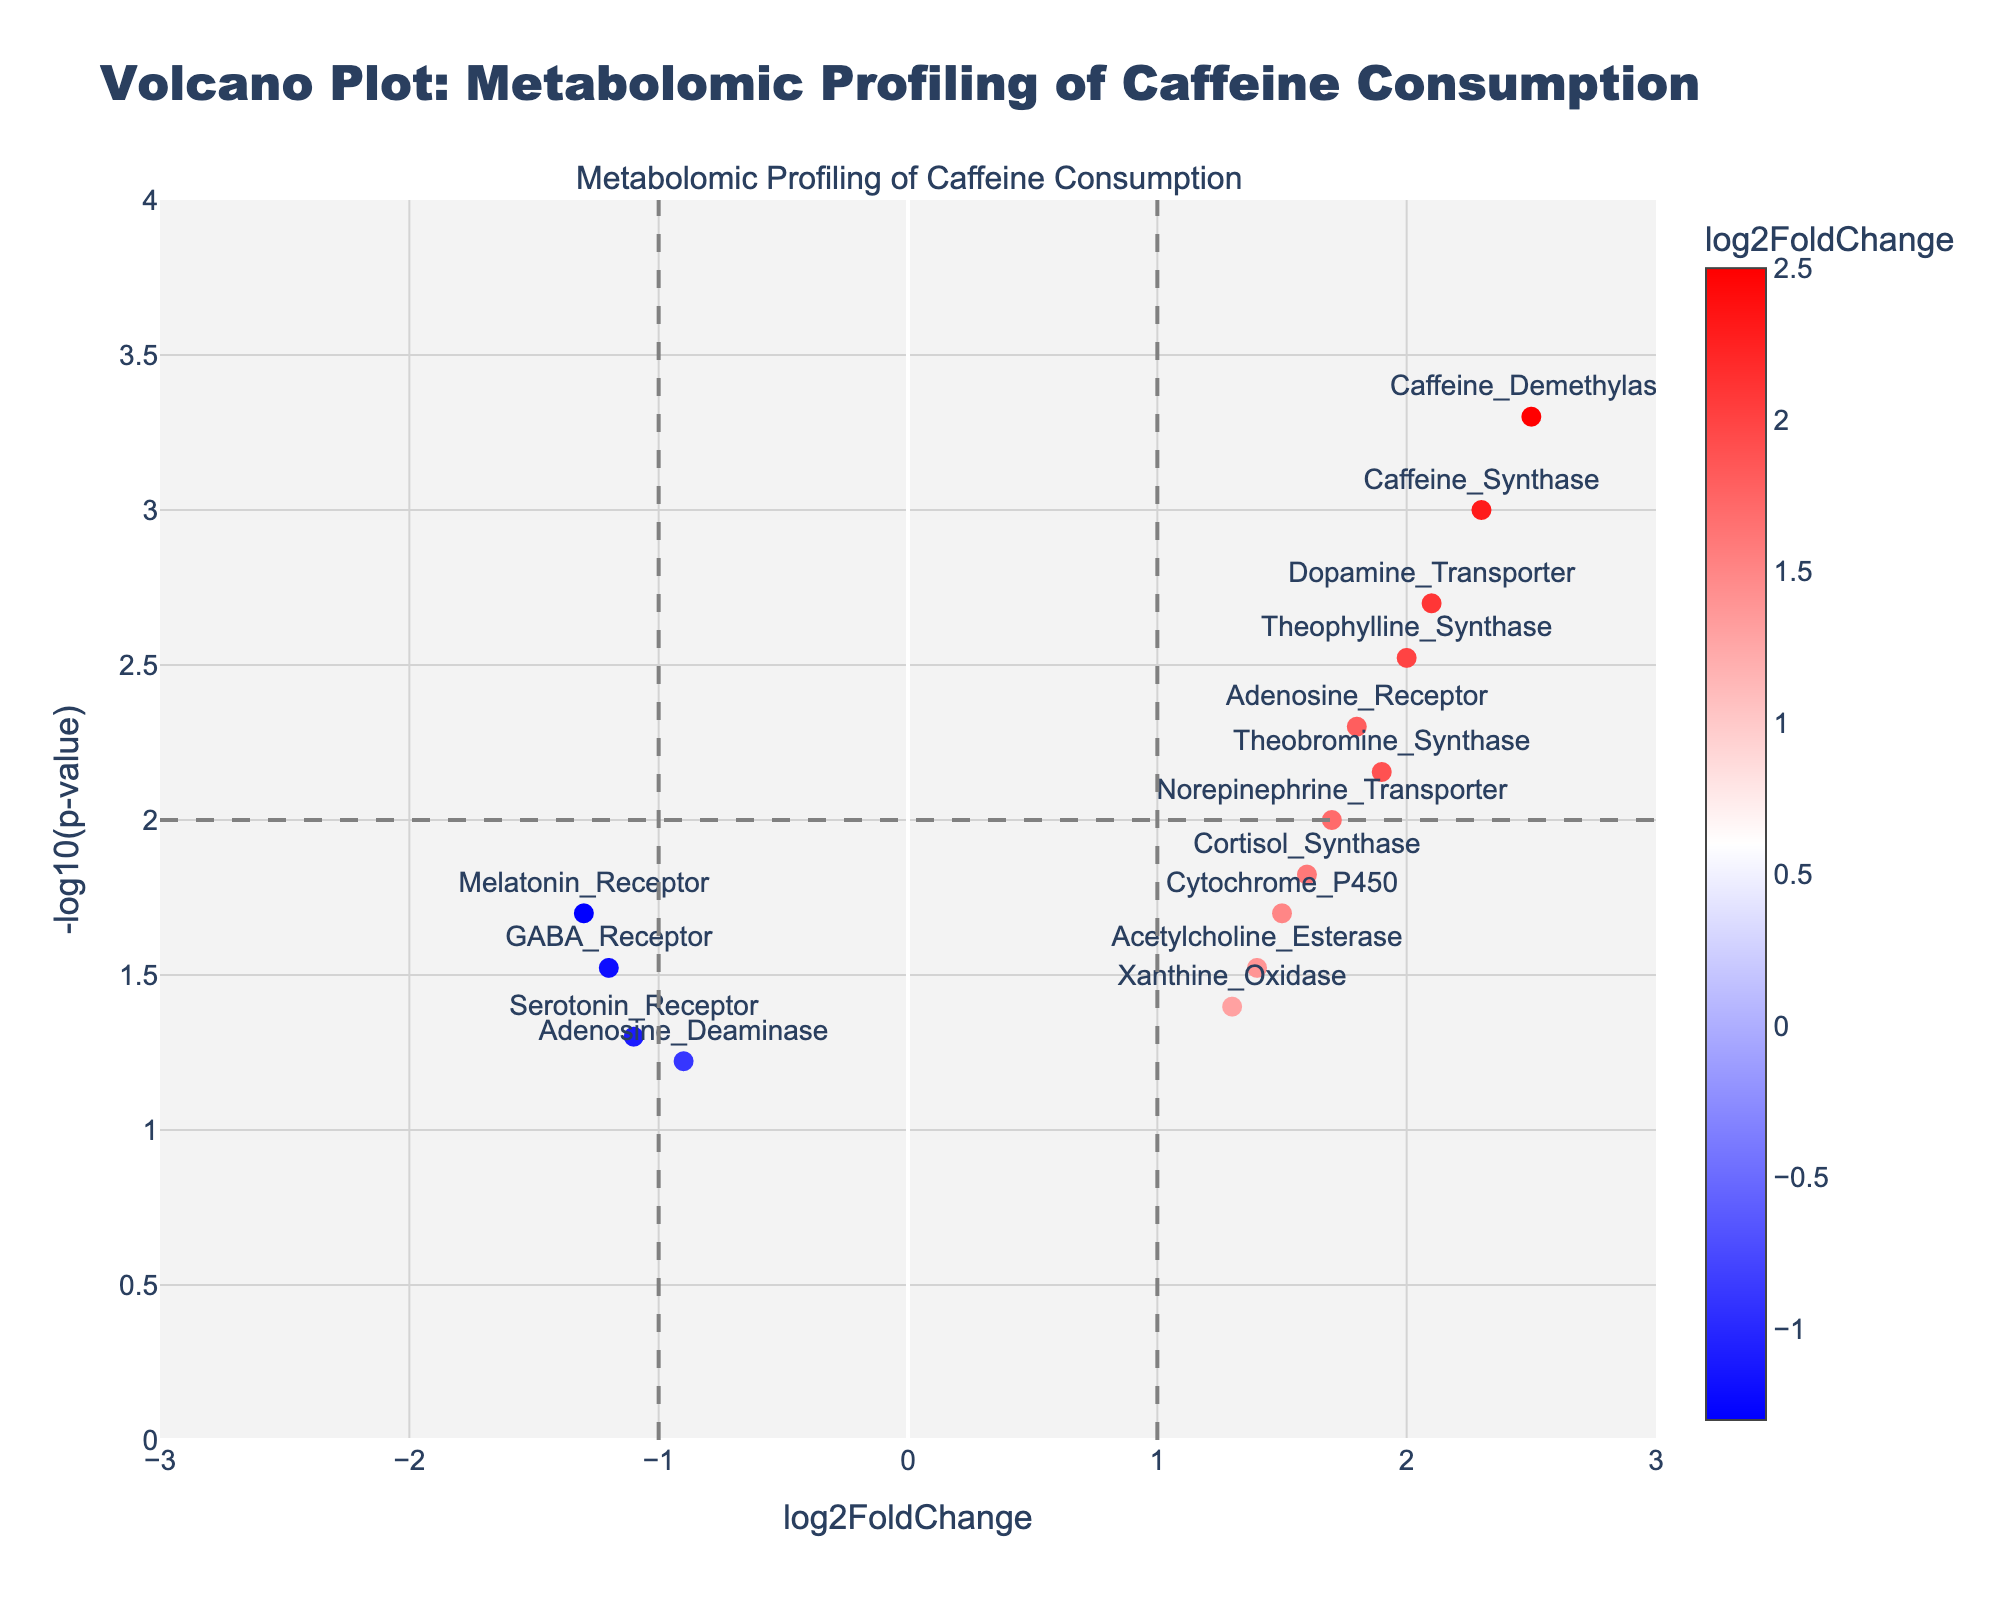What is the title of the plot? The title can be found at the top of the plot. It usually summarizes the main topic or focus of the visualization.
Answer: Volcano Plot: Metabolomic Profiling of Caffeine Consumption What is the highest log2FoldChange value and which gene does it correspond to? To find this, look at the x-axis (log2FoldChange) and identify the point that is furthest to the right. Check the text label associated with this point.
Answer: 2.5, Caffeine_Demethylase Which gene has the lowest -log10(p-value)? Look at the y-axis (-log10(p-value)) and find the point that is closest to the bottom. The text label next to this point will indicate the gene.
Answer: Adenosine_Deaminase How many genes have a log2FoldChange greater than 1.5? Identify data points with x-axis values greater than 1.5. Count these points based on their position on the x-axis.
Answer: 7 Which genes show a negative log2FoldChange, and what are their -log10(p-value) values? Look for points with x-axis values less than 0, indicating negative log2FoldChange. Check the y-axis values for these points.
Answer: GABA_Receptor (1.52), Adenosine_Deaminase (1.22), Serotonin_Receptor (1.30), Melatonin_Receptor (1.70) Is there a gene with a log2FoldChange between 1.5 and 2.0 and a -log10(p-value) greater than 2? Find points in the specified range on the x-axis (1.5 < x < 2.0) and check their positions on the y-axis to see if they are greater than 2.
Answer: No Which gene is marked with the highest -log10(p-value), and what is its log2FoldChange? Look at the highest point on the y-axis and identify the corresponding x-axis value and gene name.
Answer: Caffeine_Demethylase, 2.5 What is the color gradient used to represent log2FoldChange values? The color gradient is visible in the legend or color bar on the side of the plot. It typically ranges from one color to another.
Answer: From blue to red Which gene has the closest log2FoldChange value to zero, and what is its -log10(p-value)? Find the data point closest to zero on the x-axis (log2FoldChange) and check its y-axis value (-log10(p-value)) and gene label.
Answer: Adenosine_Deaminase, 1.22 How many genes have a p-value less than 0.01? Use the -log10(p-value) to determine this. For a p-value less than 0.01, -log10(p-value) would be greater than 2. Count the points above this threshold on the y-axis.
Answer: 5 What pattern do you observe with genes having high log2FoldChange values in terms of their -log10(p-value)? Check the distribution of points with high log2FoldChange values and note their y-axis positions, which indicate -log10(p-value).
Answer: They generally correspond to higher -log10(p-value) values 